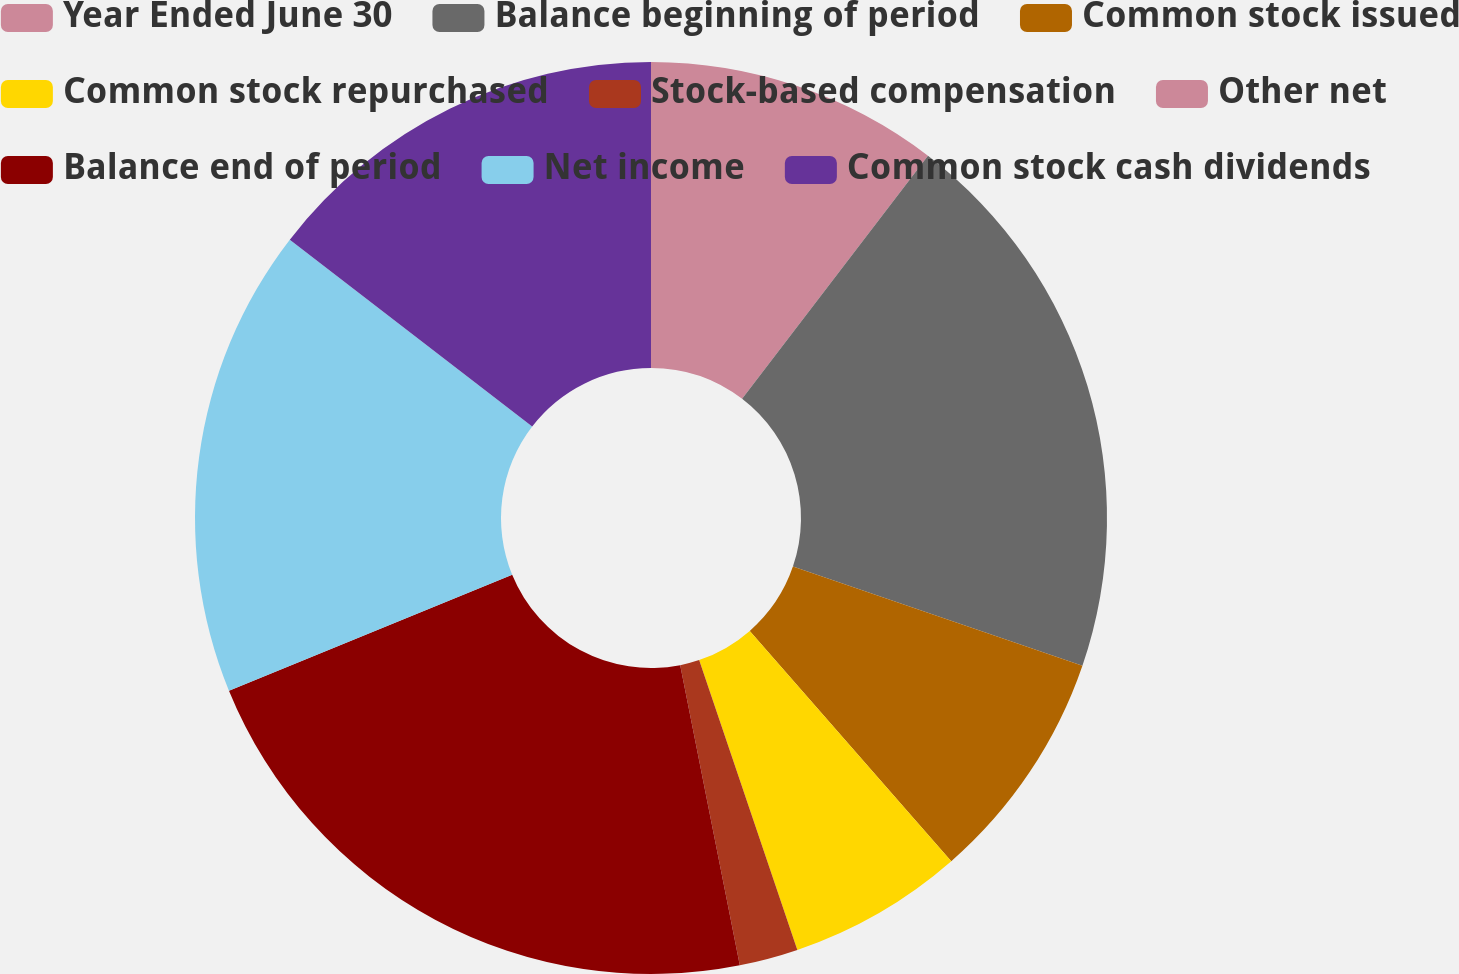<chart> <loc_0><loc_0><loc_500><loc_500><pie_chart><fcel>Year Ended June 30<fcel>Balance beginning of period<fcel>Common stock issued<fcel>Common stock repurchased<fcel>Stock-based compensation<fcel>Other net<fcel>Balance end of period<fcel>Net income<fcel>Common stock cash dividends<nl><fcel>10.39%<fcel>19.86%<fcel>8.31%<fcel>6.24%<fcel>2.08%<fcel>0.0%<fcel>21.94%<fcel>16.63%<fcel>14.55%<nl></chart> 